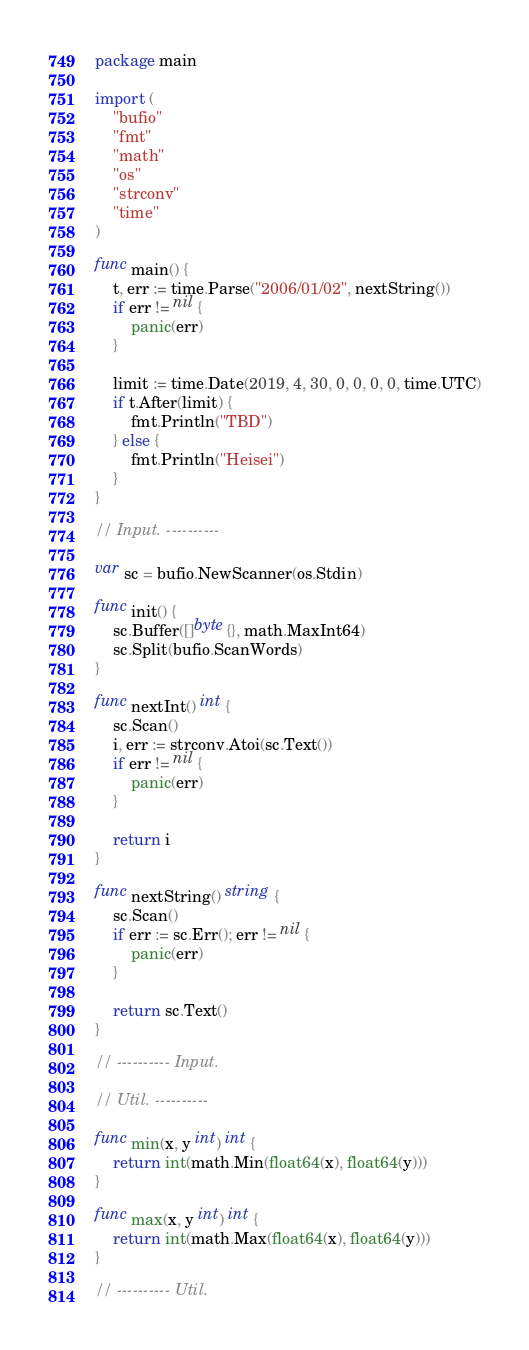Convert code to text. <code><loc_0><loc_0><loc_500><loc_500><_Go_>package main

import (
	"bufio"
	"fmt"
	"math"
	"os"
	"strconv"
	"time"
)

func main() {
	t, err := time.Parse("2006/01/02", nextString())
	if err != nil {
		panic(err)
	}

	limit := time.Date(2019, 4, 30, 0, 0, 0, 0, time.UTC)
	if t.After(limit) {
		fmt.Println("TBD")
	} else {
		fmt.Println("Heisei")
	}
}

// Input. ----------

var sc = bufio.NewScanner(os.Stdin)

func init() {
	sc.Buffer([]byte{}, math.MaxInt64)
	sc.Split(bufio.ScanWords)
}

func nextInt() int {
	sc.Scan()
	i, err := strconv.Atoi(sc.Text())
	if err != nil {
		panic(err)
	}

	return i
}

func nextString() string {
	sc.Scan()
	if err := sc.Err(); err != nil {
		panic(err)
	}

	return sc.Text()
}

// ---------- Input.

// Util. ----------

func min(x, y int) int {
	return int(math.Min(float64(x), float64(y)))
}

func max(x, y int) int {
	return int(math.Max(float64(x), float64(y)))
}

// ---------- Util.
</code> 